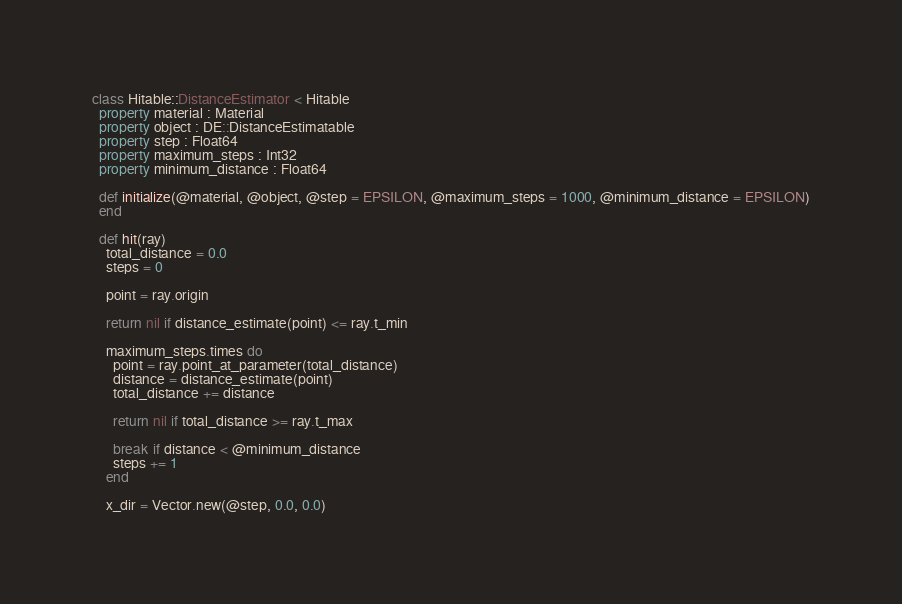<code> <loc_0><loc_0><loc_500><loc_500><_Crystal_>
class Hitable::DistanceEstimator < Hitable
  property material : Material
  property object : DE::DistanceEstimatable
  property step : Float64
  property maximum_steps : Int32
  property minimum_distance : Float64

  def initialize(@material, @object, @step = EPSILON, @maximum_steps = 1000, @minimum_distance = EPSILON)
  end

  def hit(ray)
    total_distance = 0.0
    steps = 0

    point = ray.origin

    return nil if distance_estimate(point) <= ray.t_min

    maximum_steps.times do
      point = ray.point_at_parameter(total_distance)
      distance = distance_estimate(point)
      total_distance += distance

      return nil if total_distance >= ray.t_max

      break if distance < @minimum_distance
      steps += 1
    end

    x_dir = Vector.new(@step, 0.0, 0.0)</code> 